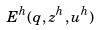<formula> <loc_0><loc_0><loc_500><loc_500>E ^ { h } ( q , z ^ { h } , u ^ { h } )</formula> 